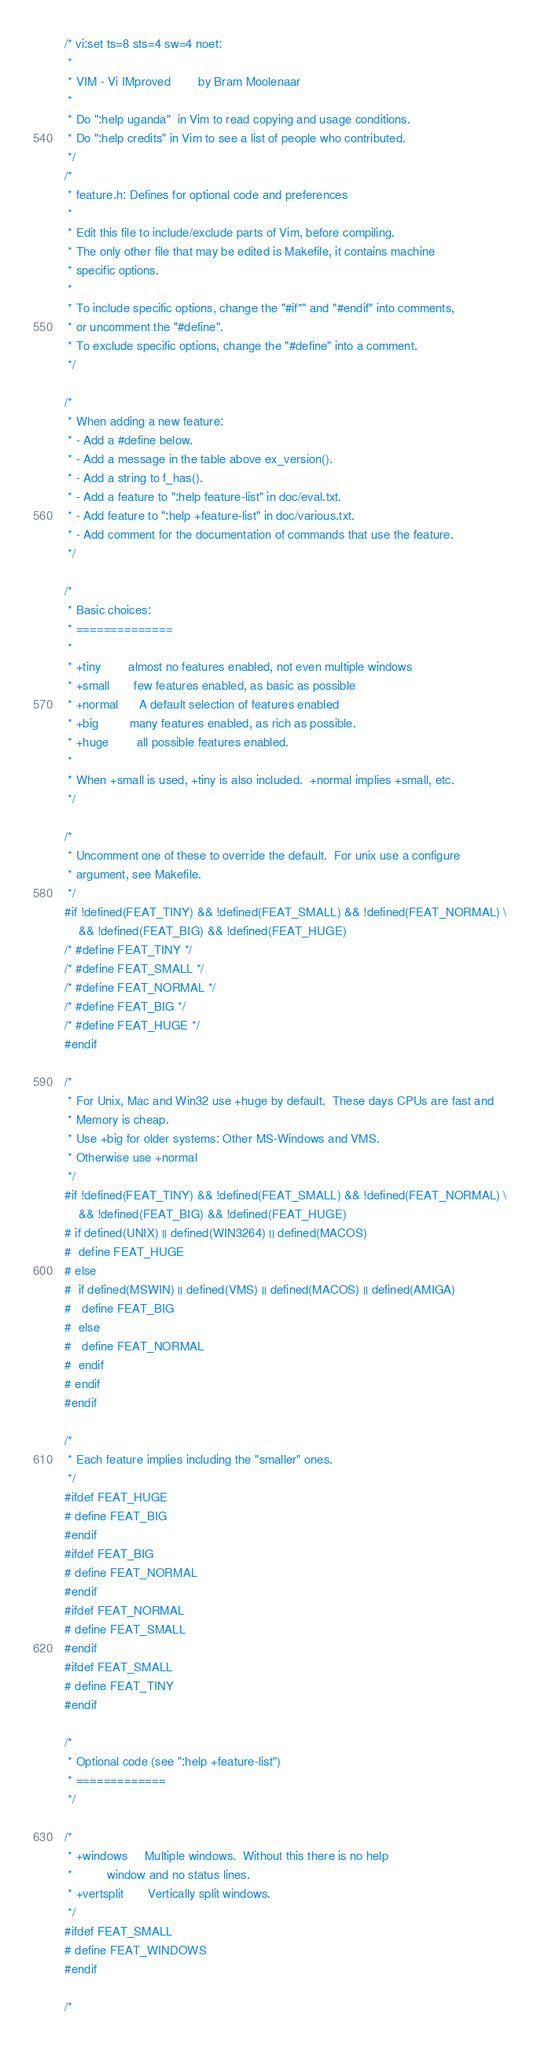Convert code to text. <code><loc_0><loc_0><loc_500><loc_500><_C_>/* vi:set ts=8 sts=4 sw=4 noet:
 *
 * VIM - Vi IMproved		by Bram Moolenaar
 *
 * Do ":help uganda"  in Vim to read copying and usage conditions.
 * Do ":help credits" in Vim to see a list of people who contributed.
 */
/*
 * feature.h: Defines for optional code and preferences
 *
 * Edit this file to include/exclude parts of Vim, before compiling.
 * The only other file that may be edited is Makefile, it contains machine
 * specific options.
 *
 * To include specific options, change the "#if*" and "#endif" into comments,
 * or uncomment the "#define".
 * To exclude specific options, change the "#define" into a comment.
 */

/*
 * When adding a new feature:
 * - Add a #define below.
 * - Add a message in the table above ex_version().
 * - Add a string to f_has().
 * - Add a feature to ":help feature-list" in doc/eval.txt.
 * - Add feature to ":help +feature-list" in doc/various.txt.
 * - Add comment for the documentation of commands that use the feature.
 */

/*
 * Basic choices:
 * ==============
 *
 * +tiny		almost no features enabled, not even multiple windows
 * +small		few features enabled, as basic as possible
 * +normal		A default selection of features enabled
 * +big			many features enabled, as rich as possible.
 * +huge		all possible features enabled.
 *
 * When +small is used, +tiny is also included.  +normal implies +small, etc.
 */

/*
 * Uncomment one of these to override the default.  For unix use a configure
 * argument, see Makefile.
 */
#if !defined(FEAT_TINY) && !defined(FEAT_SMALL) && !defined(FEAT_NORMAL) \
	&& !defined(FEAT_BIG) && !defined(FEAT_HUGE)
/* #define FEAT_TINY */
/* #define FEAT_SMALL */
/* #define FEAT_NORMAL */
/* #define FEAT_BIG */
/* #define FEAT_HUGE */
#endif

/*
 * For Unix, Mac and Win32 use +huge by default.  These days CPUs are fast and
 * Memory is cheap.
 * Use +big for older systems: Other MS-Windows and VMS.
 * Otherwise use +normal
 */
#if !defined(FEAT_TINY) && !defined(FEAT_SMALL) && !defined(FEAT_NORMAL) \
	&& !defined(FEAT_BIG) && !defined(FEAT_HUGE)
# if defined(UNIX) || defined(WIN3264) || defined(MACOS)
#  define FEAT_HUGE
# else
#  if defined(MSWIN) || defined(VMS) || defined(MACOS) || defined(AMIGA)
#   define FEAT_BIG
#  else
#   define FEAT_NORMAL
#  endif
# endif
#endif

/*
 * Each feature implies including the "smaller" ones.
 */
#ifdef FEAT_HUGE
# define FEAT_BIG
#endif
#ifdef FEAT_BIG
# define FEAT_NORMAL
#endif
#ifdef FEAT_NORMAL
# define FEAT_SMALL
#endif
#ifdef FEAT_SMALL
# define FEAT_TINY
#endif

/*
 * Optional code (see ":help +feature-list")
 * =============
 */

/*
 * +windows		Multiple windows.  Without this there is no help
 *			window and no status lines.
 * +vertsplit		Vertically split windows.
 */
#ifdef FEAT_SMALL
# define FEAT_WINDOWS
#endif

/*</code> 